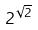Convert formula to latex. <formula><loc_0><loc_0><loc_500><loc_500>2 ^ { \sqrt { 2 } }</formula> 